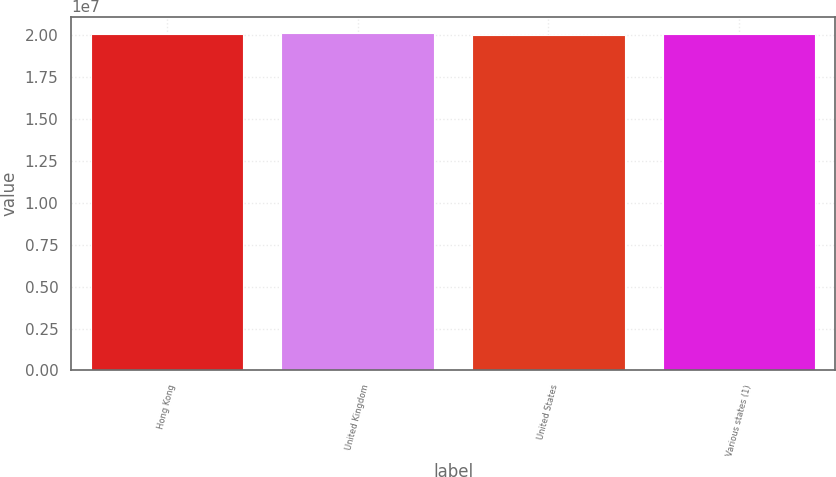<chart> <loc_0><loc_0><loc_500><loc_500><bar_chart><fcel>Hong Kong<fcel>United Kingdom<fcel>United States<fcel>Various states (1)<nl><fcel>2.0082e+07<fcel>2.0122e+07<fcel>2.0042e+07<fcel>2.0072e+07<nl></chart> 